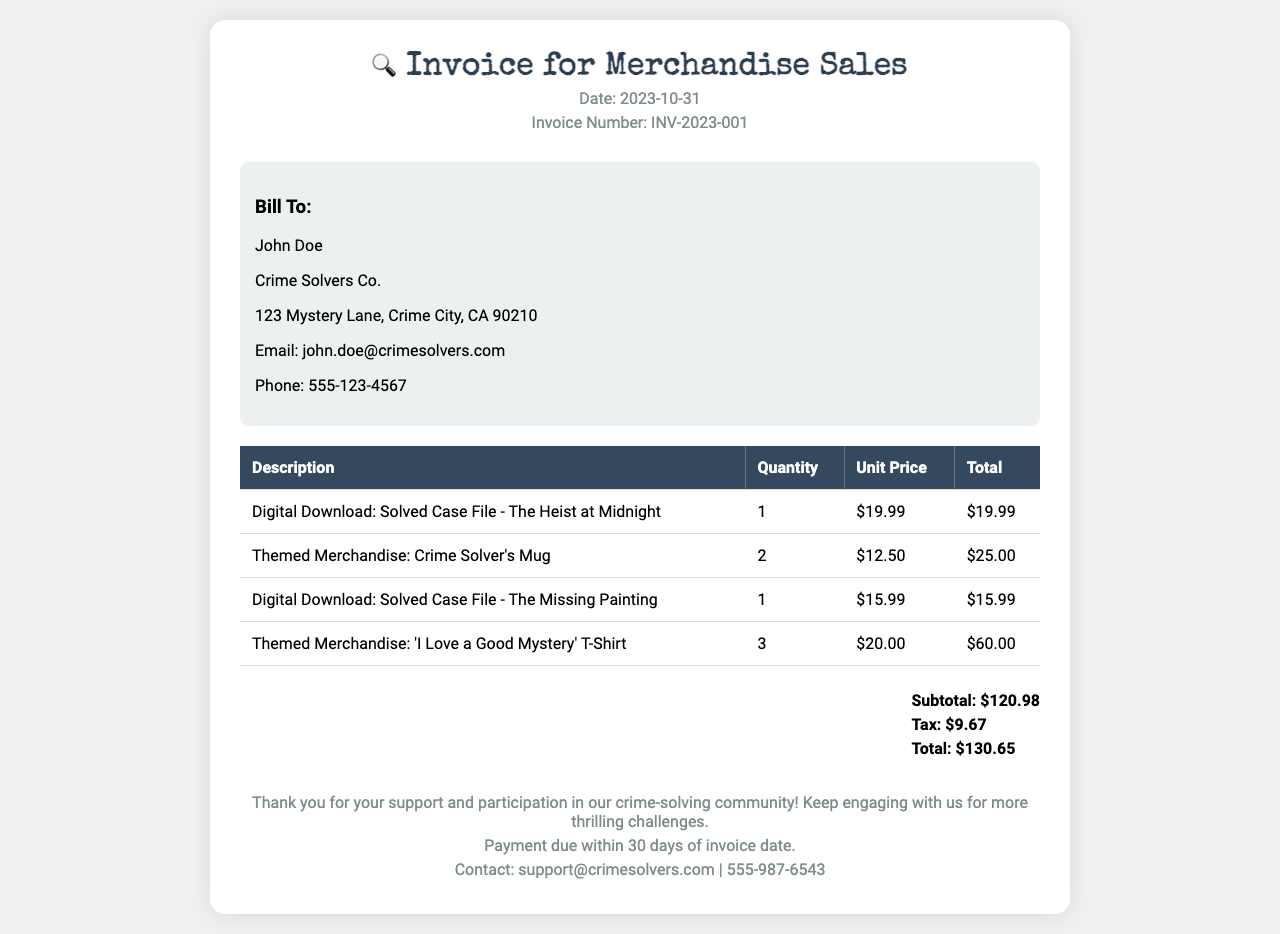What is the invoice date? The invoice date is specifically mentioned in the document under the header section.
Answer: 2023-10-31 Who is the invoice billed to? The billing information section provides the name of the person and the company being billed.
Answer: John Doe What is the total amount due? The total amount due is listed in the summary section of the invoice.
Answer: $130.65 How many 'I Love a Good Mystery' T-Shirts were purchased? The quantity of the T-shirts is found in the table listing the purchased items.
Answer: 3 What is the unit price of the Crime Solver's Mug? The unit price can be found in the itemized table under the themed merchandise section.
Answer: $12.50 What is the subtotal before tax? The subtotal is calculated before adding tax, as listed in the summary section.
Answer: $120.98 How many solved case files were purchased in total? The total number of digital downloads can be inferred by counting the relevant items in the table.
Answer: 2 What type of merchandise is referenced as themed? This refers to products designed around the crime-solving theme, which is specifically stated in the items.
Answer: Mug and T-Shirt What is the tax amount charged? The tax amount is detailed in the summary section of the invoice.
Answer: $9.67 